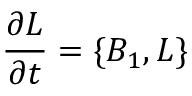Convert formula to latex. <formula><loc_0><loc_0><loc_500><loc_500>{ \frac { \partial L } { \partial t } } = \{ B _ { 1 } , L \}</formula> 